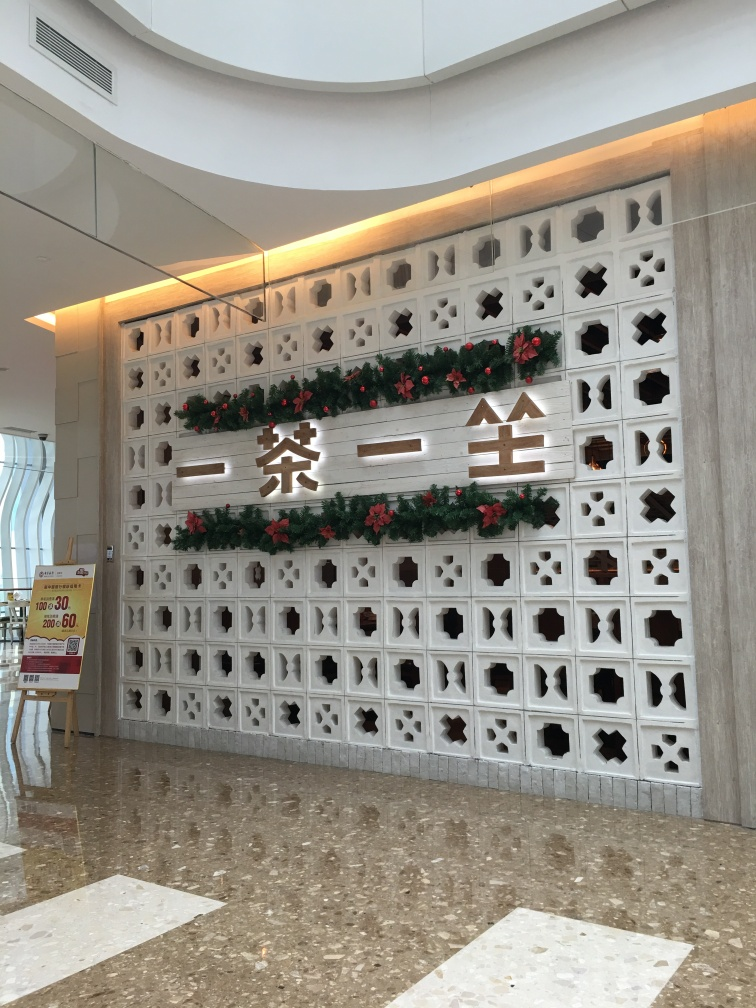How does the lighting in the area affect the ambiance? The soft, overhead lighting in the photograph creates a warm and welcoming atmosphere, highlighting the intricate details of the wall. It enhances the textures of the decorations and casts soft shadows that add depth to the space. This kind of lighting supports a calm ambience, making it suitable for both formal and casual gatherings, reflecting a thoughtful architectural design. 